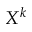<formula> <loc_0><loc_0><loc_500><loc_500>X ^ { k }</formula> 